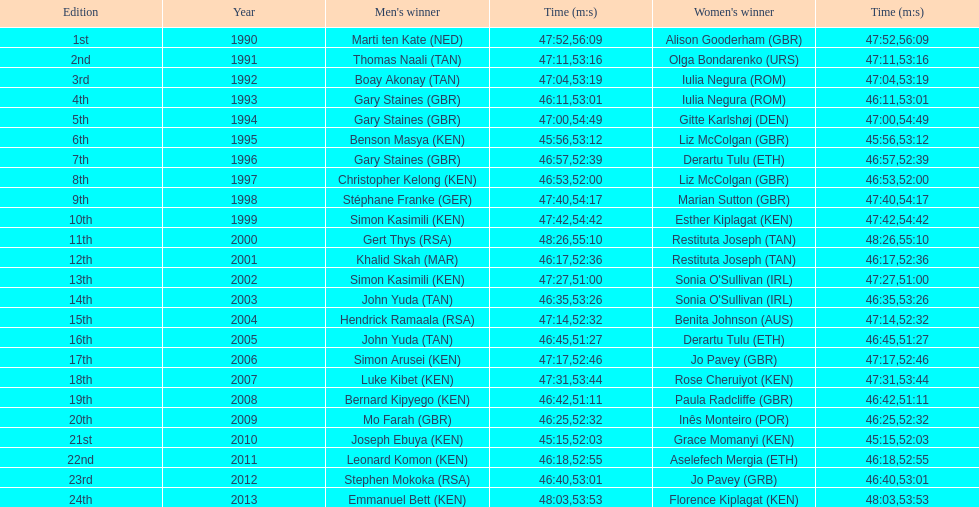Who is the male champion listed prior to gert thys? Simon Kasimili. 